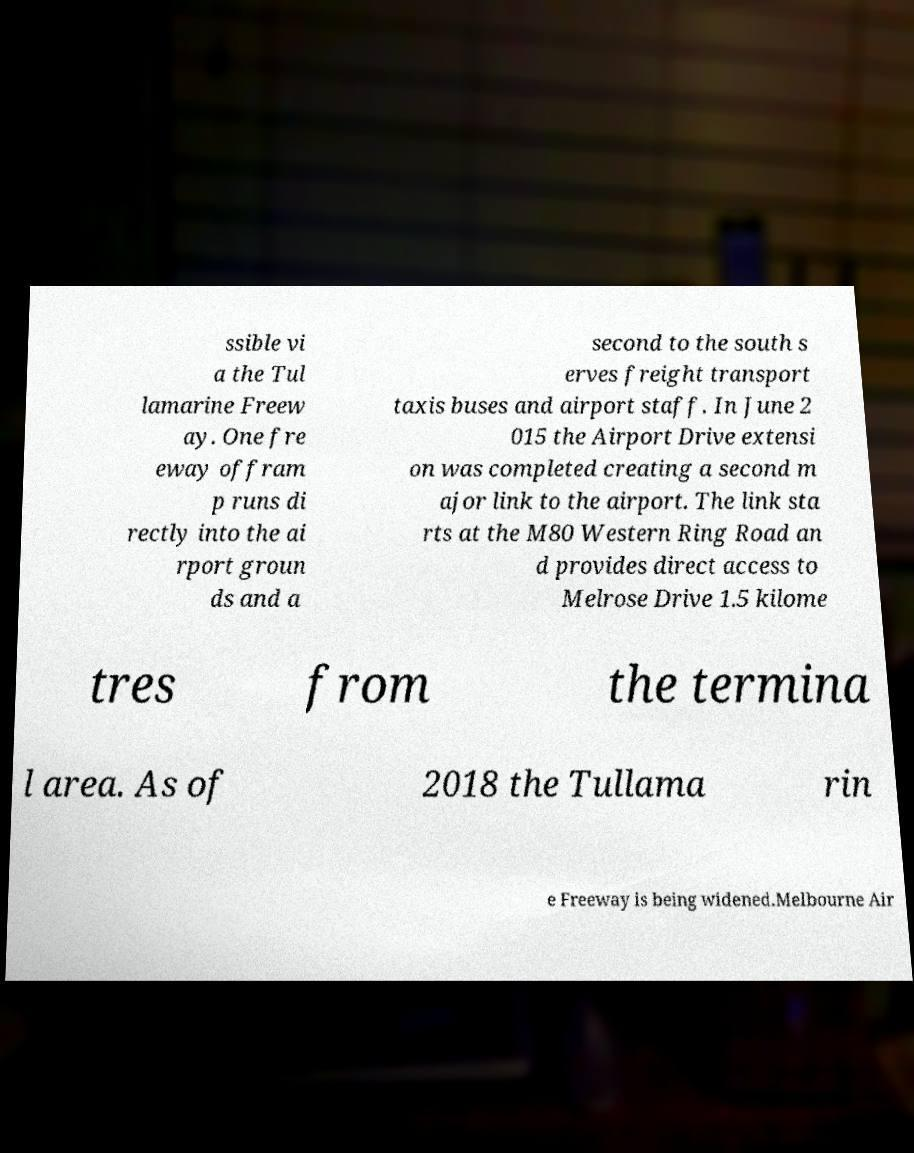For documentation purposes, I need the text within this image transcribed. Could you provide that? ssible vi a the Tul lamarine Freew ay. One fre eway offram p runs di rectly into the ai rport groun ds and a second to the south s erves freight transport taxis buses and airport staff. In June 2 015 the Airport Drive extensi on was completed creating a second m ajor link to the airport. The link sta rts at the M80 Western Ring Road an d provides direct access to Melrose Drive 1.5 kilome tres from the termina l area. As of 2018 the Tullama rin e Freeway is being widened.Melbourne Air 